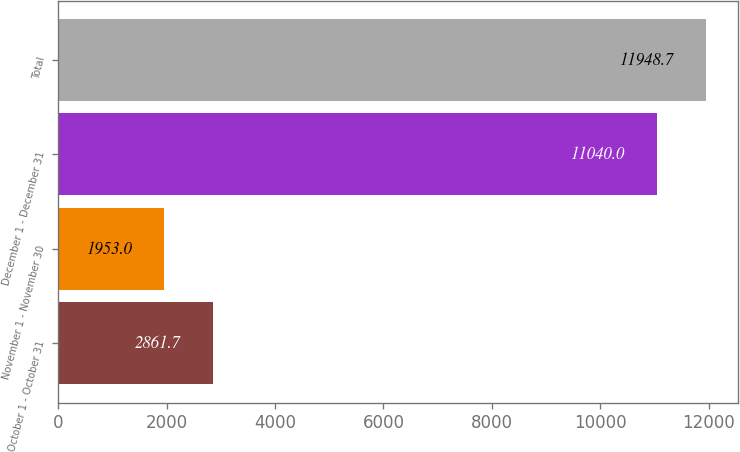Convert chart. <chart><loc_0><loc_0><loc_500><loc_500><bar_chart><fcel>October 1 - October 31<fcel>November 1 - November 30<fcel>December 1 - December 31<fcel>Total<nl><fcel>2861.7<fcel>1953<fcel>11040<fcel>11948.7<nl></chart> 